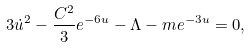Convert formula to latex. <formula><loc_0><loc_0><loc_500><loc_500>3 \dot { u } ^ { 2 } - \frac { C ^ { 2 } } { 3 } e ^ { - 6 u } - \Lambda - m e ^ { - 3 u } = 0 ,</formula> 